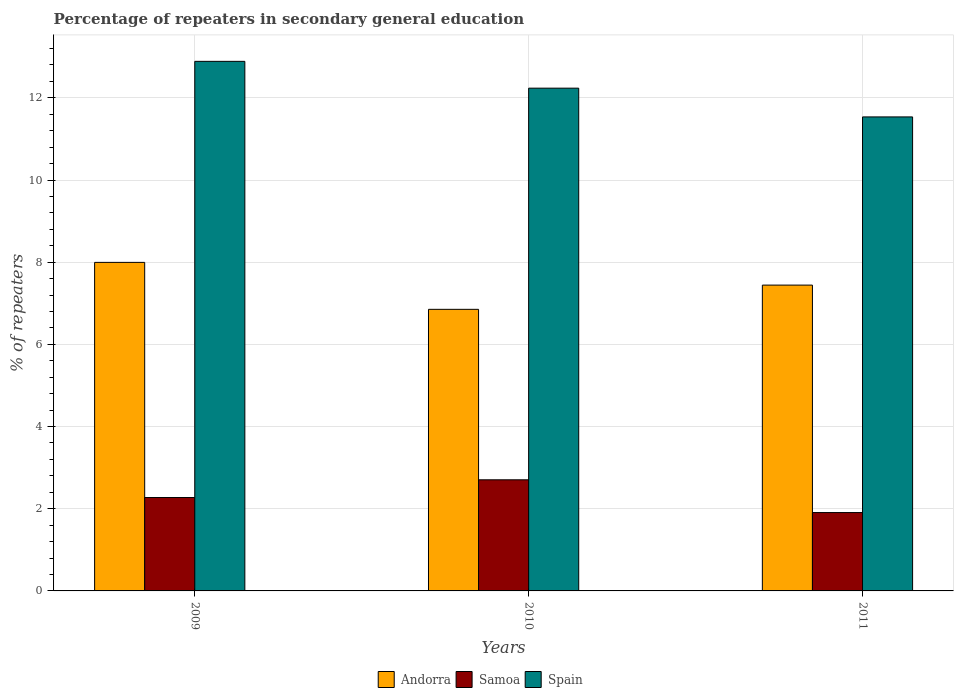How many different coloured bars are there?
Offer a very short reply. 3. How many groups of bars are there?
Provide a short and direct response. 3. How many bars are there on the 2nd tick from the left?
Provide a succinct answer. 3. What is the label of the 3rd group of bars from the left?
Provide a succinct answer. 2011. What is the percentage of repeaters in secondary general education in Spain in 2010?
Keep it short and to the point. 12.24. Across all years, what is the maximum percentage of repeaters in secondary general education in Andorra?
Make the answer very short. 8. Across all years, what is the minimum percentage of repeaters in secondary general education in Samoa?
Offer a terse response. 1.91. In which year was the percentage of repeaters in secondary general education in Samoa minimum?
Your answer should be very brief. 2011. What is the total percentage of repeaters in secondary general education in Samoa in the graph?
Your answer should be compact. 6.88. What is the difference between the percentage of repeaters in secondary general education in Andorra in 2009 and that in 2011?
Provide a short and direct response. 0.55. What is the difference between the percentage of repeaters in secondary general education in Samoa in 2011 and the percentage of repeaters in secondary general education in Andorra in 2009?
Provide a succinct answer. -6.09. What is the average percentage of repeaters in secondary general education in Spain per year?
Make the answer very short. 12.22. In the year 2010, what is the difference between the percentage of repeaters in secondary general education in Andorra and percentage of repeaters in secondary general education in Samoa?
Your answer should be compact. 4.15. In how many years, is the percentage of repeaters in secondary general education in Andorra greater than 8.4 %?
Make the answer very short. 0. What is the ratio of the percentage of repeaters in secondary general education in Samoa in 2009 to that in 2010?
Offer a very short reply. 0.84. Is the percentage of repeaters in secondary general education in Spain in 2010 less than that in 2011?
Your response must be concise. No. Is the difference between the percentage of repeaters in secondary general education in Andorra in 2010 and 2011 greater than the difference between the percentage of repeaters in secondary general education in Samoa in 2010 and 2011?
Make the answer very short. No. What is the difference between the highest and the second highest percentage of repeaters in secondary general education in Samoa?
Ensure brevity in your answer.  0.43. What is the difference between the highest and the lowest percentage of repeaters in secondary general education in Spain?
Give a very brief answer. 1.35. In how many years, is the percentage of repeaters in secondary general education in Andorra greater than the average percentage of repeaters in secondary general education in Andorra taken over all years?
Keep it short and to the point. 2. Is the sum of the percentage of repeaters in secondary general education in Spain in 2009 and 2011 greater than the maximum percentage of repeaters in secondary general education in Andorra across all years?
Your answer should be very brief. Yes. What does the 1st bar from the left in 2011 represents?
Your answer should be very brief. Andorra. How many bars are there?
Ensure brevity in your answer.  9. Are all the bars in the graph horizontal?
Provide a short and direct response. No. How many years are there in the graph?
Give a very brief answer. 3. What is the difference between two consecutive major ticks on the Y-axis?
Your answer should be very brief. 2. Are the values on the major ticks of Y-axis written in scientific E-notation?
Provide a succinct answer. No. Does the graph contain grids?
Make the answer very short. Yes. Where does the legend appear in the graph?
Your response must be concise. Bottom center. How many legend labels are there?
Give a very brief answer. 3. What is the title of the graph?
Your answer should be compact. Percentage of repeaters in secondary general education. What is the label or title of the X-axis?
Provide a short and direct response. Years. What is the label or title of the Y-axis?
Provide a short and direct response. % of repeaters. What is the % of repeaters of Andorra in 2009?
Ensure brevity in your answer.  8. What is the % of repeaters in Samoa in 2009?
Ensure brevity in your answer.  2.27. What is the % of repeaters of Spain in 2009?
Offer a terse response. 12.89. What is the % of repeaters of Andorra in 2010?
Make the answer very short. 6.85. What is the % of repeaters of Samoa in 2010?
Ensure brevity in your answer.  2.7. What is the % of repeaters of Spain in 2010?
Your response must be concise. 12.24. What is the % of repeaters of Andorra in 2011?
Give a very brief answer. 7.44. What is the % of repeaters in Samoa in 2011?
Give a very brief answer. 1.91. What is the % of repeaters of Spain in 2011?
Offer a very short reply. 11.54. Across all years, what is the maximum % of repeaters in Andorra?
Make the answer very short. 8. Across all years, what is the maximum % of repeaters of Samoa?
Your answer should be very brief. 2.7. Across all years, what is the maximum % of repeaters in Spain?
Your answer should be very brief. 12.89. Across all years, what is the minimum % of repeaters in Andorra?
Offer a very short reply. 6.85. Across all years, what is the minimum % of repeaters of Samoa?
Offer a terse response. 1.91. Across all years, what is the minimum % of repeaters in Spain?
Offer a terse response. 11.54. What is the total % of repeaters of Andorra in the graph?
Provide a succinct answer. 22.29. What is the total % of repeaters in Samoa in the graph?
Keep it short and to the point. 6.88. What is the total % of repeaters in Spain in the graph?
Give a very brief answer. 36.66. What is the difference between the % of repeaters of Andorra in 2009 and that in 2010?
Ensure brevity in your answer.  1.14. What is the difference between the % of repeaters of Samoa in 2009 and that in 2010?
Offer a very short reply. -0.43. What is the difference between the % of repeaters of Spain in 2009 and that in 2010?
Offer a very short reply. 0.65. What is the difference between the % of repeaters in Andorra in 2009 and that in 2011?
Ensure brevity in your answer.  0.55. What is the difference between the % of repeaters in Samoa in 2009 and that in 2011?
Make the answer very short. 0.37. What is the difference between the % of repeaters in Spain in 2009 and that in 2011?
Offer a terse response. 1.35. What is the difference between the % of repeaters in Andorra in 2010 and that in 2011?
Give a very brief answer. -0.59. What is the difference between the % of repeaters of Samoa in 2010 and that in 2011?
Your response must be concise. 0.8. What is the difference between the % of repeaters of Spain in 2010 and that in 2011?
Offer a terse response. 0.7. What is the difference between the % of repeaters in Andorra in 2009 and the % of repeaters in Samoa in 2010?
Provide a succinct answer. 5.29. What is the difference between the % of repeaters in Andorra in 2009 and the % of repeaters in Spain in 2010?
Give a very brief answer. -4.24. What is the difference between the % of repeaters in Samoa in 2009 and the % of repeaters in Spain in 2010?
Your answer should be compact. -9.96. What is the difference between the % of repeaters in Andorra in 2009 and the % of repeaters in Samoa in 2011?
Provide a succinct answer. 6.09. What is the difference between the % of repeaters in Andorra in 2009 and the % of repeaters in Spain in 2011?
Keep it short and to the point. -3.54. What is the difference between the % of repeaters of Samoa in 2009 and the % of repeaters of Spain in 2011?
Your response must be concise. -9.26. What is the difference between the % of repeaters of Andorra in 2010 and the % of repeaters of Samoa in 2011?
Your answer should be compact. 4.95. What is the difference between the % of repeaters of Andorra in 2010 and the % of repeaters of Spain in 2011?
Keep it short and to the point. -4.68. What is the difference between the % of repeaters in Samoa in 2010 and the % of repeaters in Spain in 2011?
Give a very brief answer. -8.83. What is the average % of repeaters in Andorra per year?
Provide a succinct answer. 7.43. What is the average % of repeaters of Samoa per year?
Make the answer very short. 2.29. What is the average % of repeaters of Spain per year?
Make the answer very short. 12.22. In the year 2009, what is the difference between the % of repeaters of Andorra and % of repeaters of Samoa?
Ensure brevity in your answer.  5.72. In the year 2009, what is the difference between the % of repeaters in Andorra and % of repeaters in Spain?
Provide a succinct answer. -4.89. In the year 2009, what is the difference between the % of repeaters of Samoa and % of repeaters of Spain?
Offer a very short reply. -10.61. In the year 2010, what is the difference between the % of repeaters of Andorra and % of repeaters of Samoa?
Keep it short and to the point. 4.15. In the year 2010, what is the difference between the % of repeaters of Andorra and % of repeaters of Spain?
Offer a very short reply. -5.38. In the year 2010, what is the difference between the % of repeaters in Samoa and % of repeaters in Spain?
Your answer should be compact. -9.53. In the year 2011, what is the difference between the % of repeaters in Andorra and % of repeaters in Samoa?
Your answer should be compact. 5.54. In the year 2011, what is the difference between the % of repeaters in Andorra and % of repeaters in Spain?
Make the answer very short. -4.09. In the year 2011, what is the difference between the % of repeaters in Samoa and % of repeaters in Spain?
Ensure brevity in your answer.  -9.63. What is the ratio of the % of repeaters of Andorra in 2009 to that in 2010?
Your answer should be very brief. 1.17. What is the ratio of the % of repeaters in Samoa in 2009 to that in 2010?
Give a very brief answer. 0.84. What is the ratio of the % of repeaters in Spain in 2009 to that in 2010?
Make the answer very short. 1.05. What is the ratio of the % of repeaters of Andorra in 2009 to that in 2011?
Your response must be concise. 1.07. What is the ratio of the % of repeaters in Samoa in 2009 to that in 2011?
Ensure brevity in your answer.  1.19. What is the ratio of the % of repeaters in Spain in 2009 to that in 2011?
Provide a short and direct response. 1.12. What is the ratio of the % of repeaters of Andorra in 2010 to that in 2011?
Your answer should be very brief. 0.92. What is the ratio of the % of repeaters in Samoa in 2010 to that in 2011?
Offer a terse response. 1.42. What is the ratio of the % of repeaters of Spain in 2010 to that in 2011?
Give a very brief answer. 1.06. What is the difference between the highest and the second highest % of repeaters of Andorra?
Your answer should be compact. 0.55. What is the difference between the highest and the second highest % of repeaters in Samoa?
Give a very brief answer. 0.43. What is the difference between the highest and the second highest % of repeaters of Spain?
Keep it short and to the point. 0.65. What is the difference between the highest and the lowest % of repeaters of Samoa?
Your answer should be very brief. 0.8. What is the difference between the highest and the lowest % of repeaters of Spain?
Make the answer very short. 1.35. 